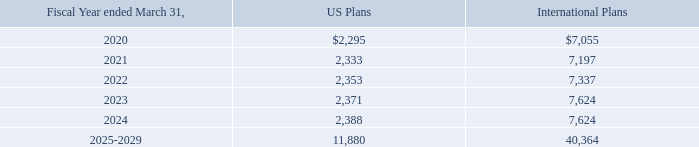We make contributions to our defined benefit plans as required under various pension funding regulations. We expect to make contributions of approximately
$1,420 to the international plans in fiscal 2020 based on current actuarial computations
Estimated future benefit payments are as follows:
Savings plans:
We sponsor retirement savings plans, which allow eligible employees to defer part of their annual compensation. Certain contributions by us are discretionary and
are determined by our Board of Directors each year. Our contributions to the savings plans in the United States for the fiscal years ended March 31, 2017, 2018 and 2019
were approximately $4,367, $4,421, and $4,913, respectively.
We also sponsor a nonqualified deferred compensation program, which permits certain employees to annually elect to defer a portion of their compensation until
retirement. A portion of the deferral is subject to a matching contribution by us. The employees select among various investment alternatives, which are the same as are
available under the retirement savings plans, with the investments held in a separate trust. The value of the participants’ balances fluctuate based on the performance of
the investments. The market value of the trust at March 31, 2018 and 2019 of $6,649 and $4,693, respectively, is included as an asset and a liability in our accompanying
balance sheet because the trust’s assets are both assets of the Company and a liability as they are available to general creditors in certain circumstances
What are the future benefit payments of U.S. Plans for the fiscal years ended March 31, 2020 to 2022? 2,295, 2,333, 2,353. What are the future benefit payments of U.S. Plans for the fiscal years ended March 31, 2022 to 2024? 2,353, 2,371, 2,388. What are the future benefit payments of International Plans for the fiscal years ended March 31, 2020 to 2022? 7,055, 7,197, 7,337. What is the difference in the 2020 U.S. and International plans? 7,055 - 2,295 
Answer: 4760. What is the total and estimated future benefits payments for the years ended March 31, 2017 to 2020 for the U.S.? 4,367 + 4,421 + 4,913 + 2,295 
Answer: 15996. What is the percentage change in the estimated future benefit payments between 2020 and 2021 for the international plans?
Answer scale should be: percent. (7,197 - 7,055)/7,055 
Answer: 2.01. 